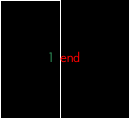<code> <loc_0><loc_0><loc_500><loc_500><_Ruby_>end
</code> 